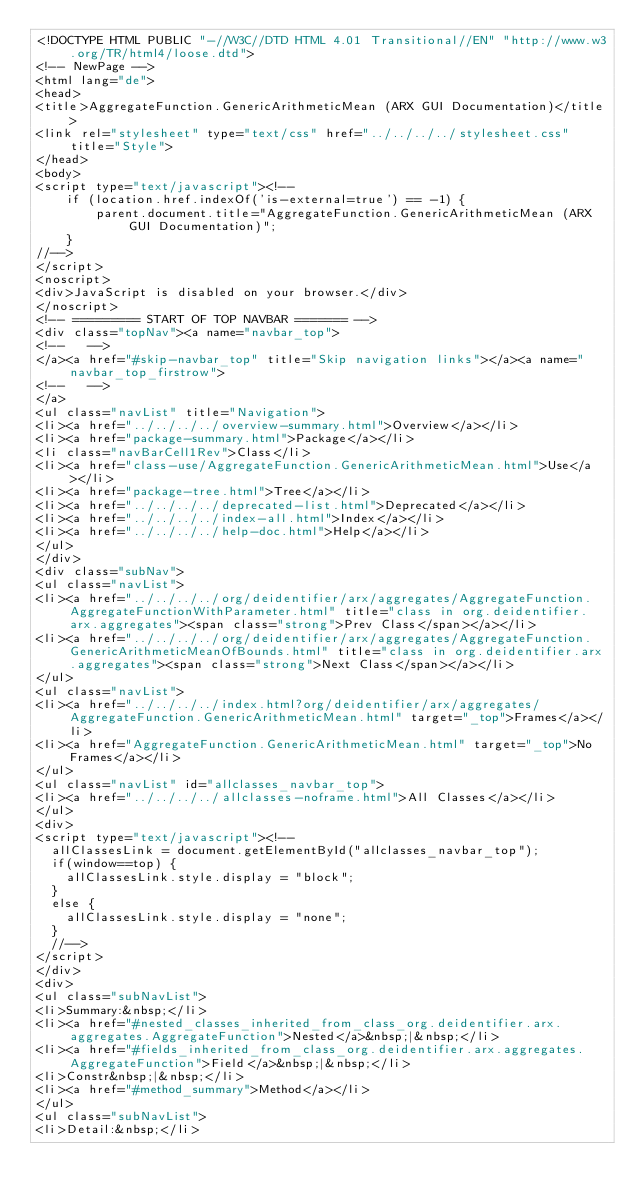Convert code to text. <code><loc_0><loc_0><loc_500><loc_500><_HTML_><!DOCTYPE HTML PUBLIC "-//W3C//DTD HTML 4.01 Transitional//EN" "http://www.w3.org/TR/html4/loose.dtd">
<!-- NewPage -->
<html lang="de">
<head>
<title>AggregateFunction.GenericArithmeticMean (ARX GUI Documentation)</title>
<link rel="stylesheet" type="text/css" href="../../../../stylesheet.css" title="Style">
</head>
<body>
<script type="text/javascript"><!--
    if (location.href.indexOf('is-external=true') == -1) {
        parent.document.title="AggregateFunction.GenericArithmeticMean (ARX GUI Documentation)";
    }
//-->
</script>
<noscript>
<div>JavaScript is disabled on your browser.</div>
</noscript>
<!-- ========= START OF TOP NAVBAR ======= -->
<div class="topNav"><a name="navbar_top">
<!--   -->
</a><a href="#skip-navbar_top" title="Skip navigation links"></a><a name="navbar_top_firstrow">
<!--   -->
</a>
<ul class="navList" title="Navigation">
<li><a href="../../../../overview-summary.html">Overview</a></li>
<li><a href="package-summary.html">Package</a></li>
<li class="navBarCell1Rev">Class</li>
<li><a href="class-use/AggregateFunction.GenericArithmeticMean.html">Use</a></li>
<li><a href="package-tree.html">Tree</a></li>
<li><a href="../../../../deprecated-list.html">Deprecated</a></li>
<li><a href="../../../../index-all.html">Index</a></li>
<li><a href="../../../../help-doc.html">Help</a></li>
</ul>
</div>
<div class="subNav">
<ul class="navList">
<li><a href="../../../../org/deidentifier/arx/aggregates/AggregateFunction.AggregateFunctionWithParameter.html" title="class in org.deidentifier.arx.aggregates"><span class="strong">Prev Class</span></a></li>
<li><a href="../../../../org/deidentifier/arx/aggregates/AggregateFunction.GenericArithmeticMeanOfBounds.html" title="class in org.deidentifier.arx.aggregates"><span class="strong">Next Class</span></a></li>
</ul>
<ul class="navList">
<li><a href="../../../../index.html?org/deidentifier/arx/aggregates/AggregateFunction.GenericArithmeticMean.html" target="_top">Frames</a></li>
<li><a href="AggregateFunction.GenericArithmeticMean.html" target="_top">No Frames</a></li>
</ul>
<ul class="navList" id="allclasses_navbar_top">
<li><a href="../../../../allclasses-noframe.html">All Classes</a></li>
</ul>
<div>
<script type="text/javascript"><!--
  allClassesLink = document.getElementById("allclasses_navbar_top");
  if(window==top) {
    allClassesLink.style.display = "block";
  }
  else {
    allClassesLink.style.display = "none";
  }
  //-->
</script>
</div>
<div>
<ul class="subNavList">
<li>Summary:&nbsp;</li>
<li><a href="#nested_classes_inherited_from_class_org.deidentifier.arx.aggregates.AggregateFunction">Nested</a>&nbsp;|&nbsp;</li>
<li><a href="#fields_inherited_from_class_org.deidentifier.arx.aggregates.AggregateFunction">Field</a>&nbsp;|&nbsp;</li>
<li>Constr&nbsp;|&nbsp;</li>
<li><a href="#method_summary">Method</a></li>
</ul>
<ul class="subNavList">
<li>Detail:&nbsp;</li></code> 